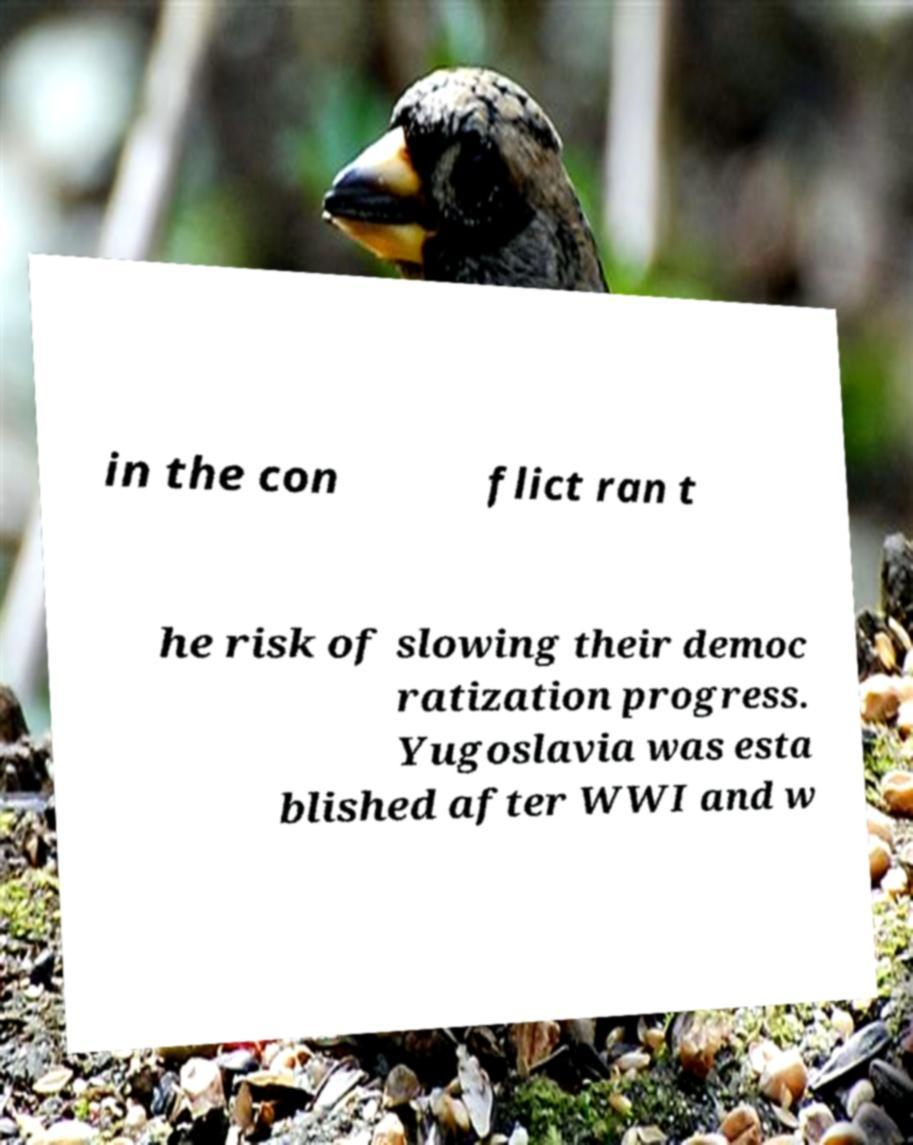Could you assist in decoding the text presented in this image and type it out clearly? in the con flict ran t he risk of slowing their democ ratization progress. Yugoslavia was esta blished after WWI and w 